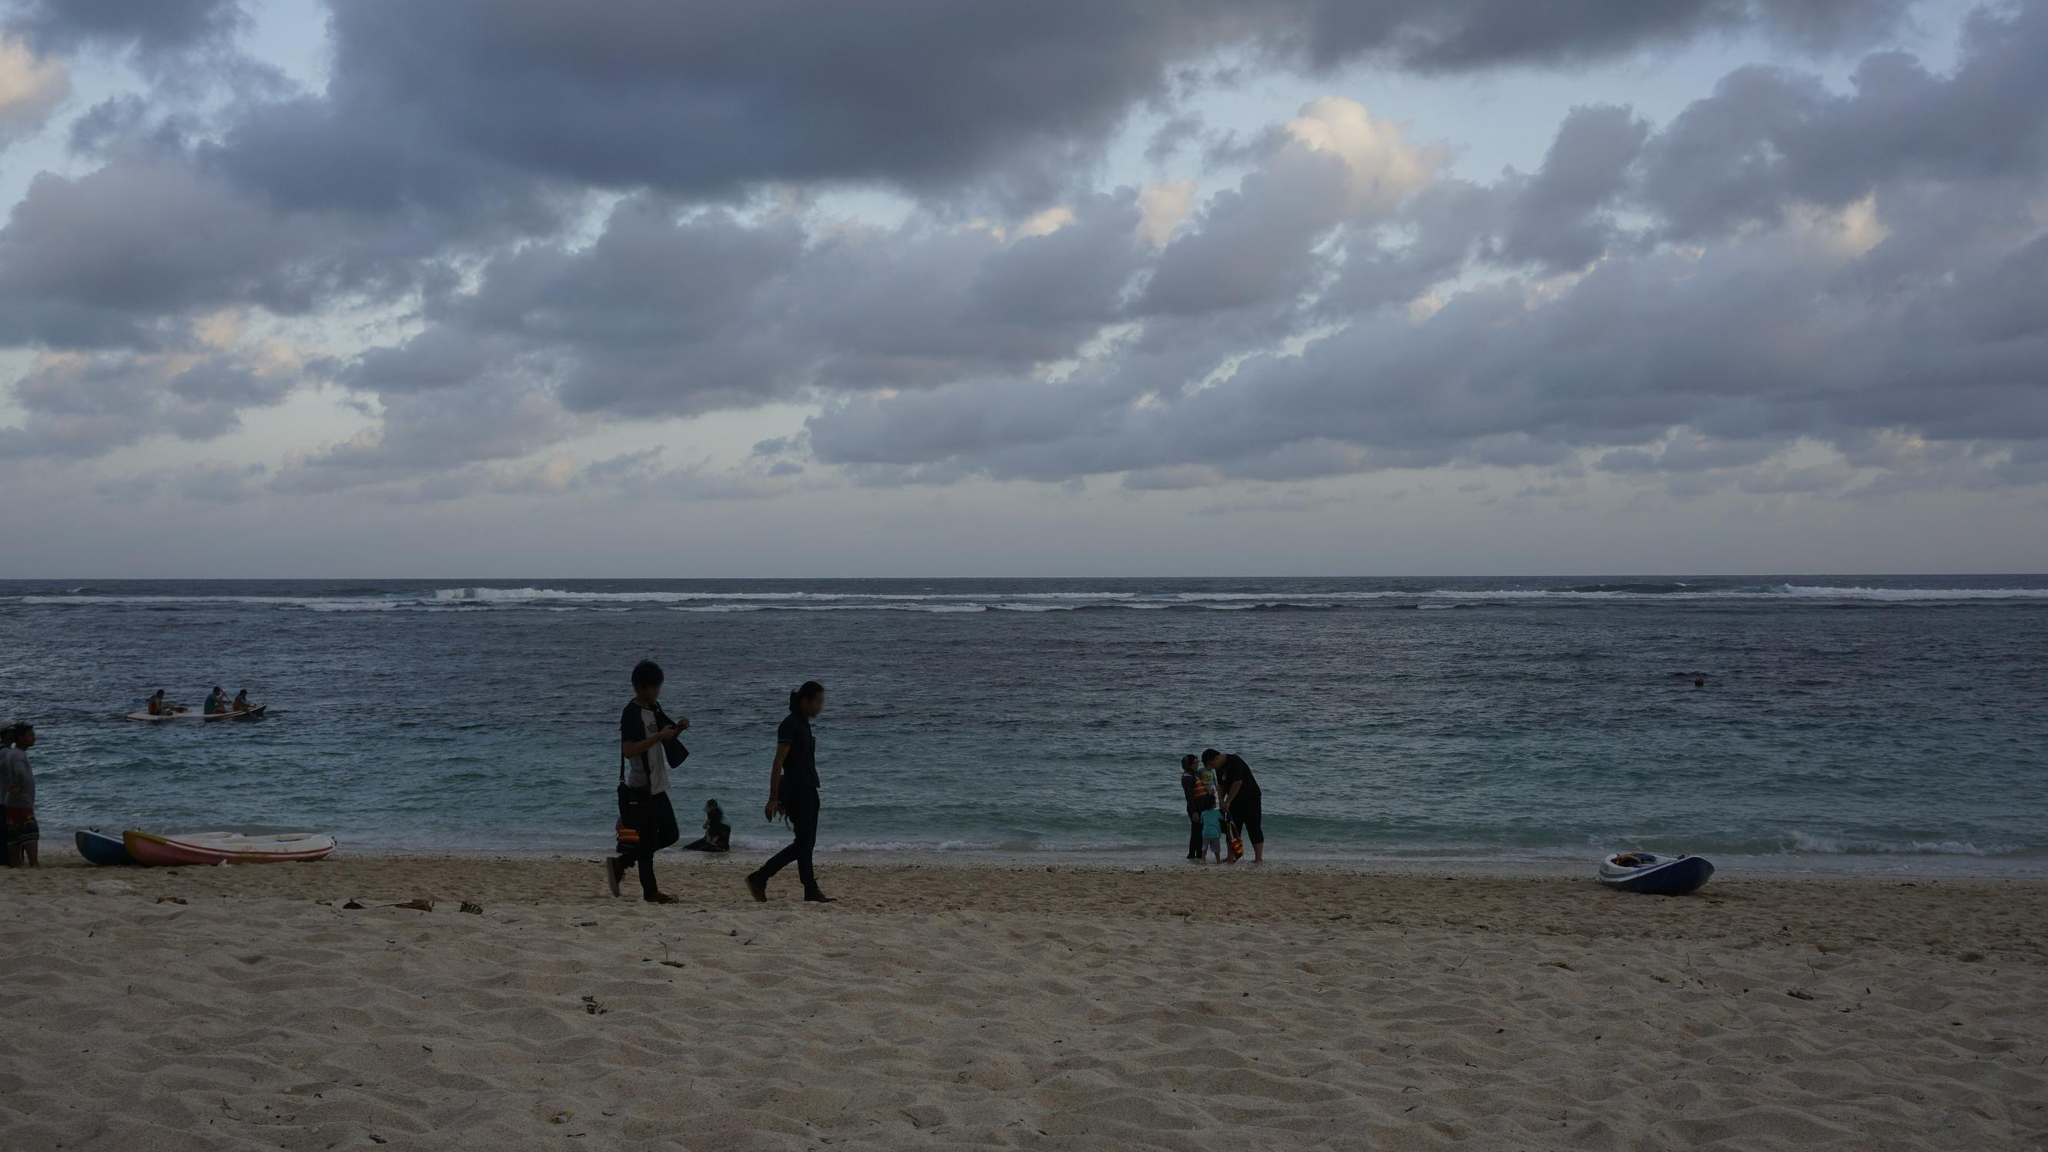Describe the following image. The image depicts a tranquil seaside scene. The beach is dotted with people engaging in leisurely activities such as walking and kayaking. The sky is overcast with thick, fluffy clouds, suggesting a calm, cool day by the ocean. The ocean itself is a vast, serene expanse, with gentle waves rolling into the shore, creating a soothing ambiance.

From a low-angle perspective, the sandy beach foreground is emphasized, with finer details like scattered kayaks - in shades of orange and red - adding a vibrant splash of color against the more subdued tones of the sea and sky. The horizon stretches out where the sea meets the cloudy sky, giving the image a sense of depth and tranquility. The overall palette is dominated by blues and grays, reflective of the overcast weather, but punctuated by the occasional lively detail, suggesting a popular coastal location that's buzzing with quiet activity. 